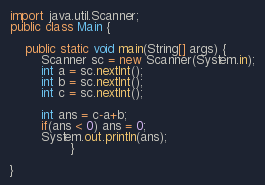<code> <loc_0><loc_0><loc_500><loc_500><_Java_>
import java.util.Scanner;
public class Main {

	public static void main(String[] args) {
		Scanner sc = new Scanner(System.in);
		int a = sc.nextInt();
		int b = sc.nextInt();
		int c = sc.nextInt();
		
		int ans = c-a+b;
		if(ans < 0) ans = 0;
		System.out.println(ans);
				}

}
</code> 